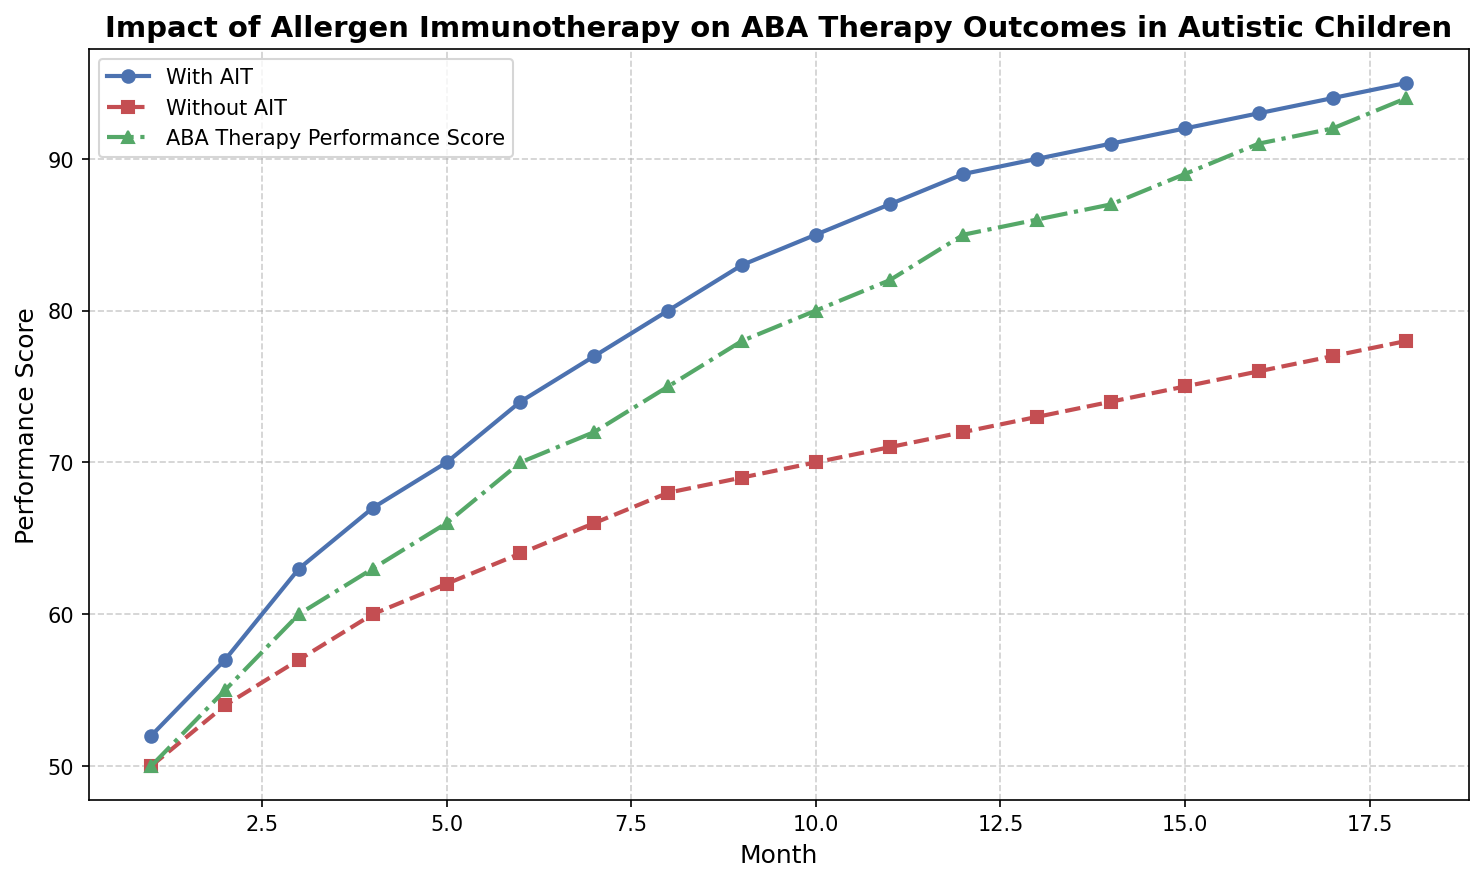What is the overall trend of the ABA Therapy Performance Score over 18 months? The ABA Therapy Performance Score shows an increasing trend over the 18 months, starting at 50 and rising to 94. This indicates an overall improvement in performance scores over time.
Answer: Increasing Comparing the 10th month scores, which group has a higher performance score, children with AIT or those without AIT? In the 10th month, children with AIT have a performance score of 85, while those without AIT have a score of 70. Therefore, children with AIT have a higher score.
Answer: Children with AIT How does the performance score for children without AIT change from the 1st month to the 18th month? The performance score for children without AIT starts at 50 in the 1st month and increases to 78 in the 18th month. The change is an increase of 28 points.
Answer: Increased by 28 points At which month do children with AIT and the general ABA Therapy Performance Score first match or exceed 85? Children with AIT first reach or exceed a score of 85 in the 10th month, while the general ABA Therapy Performance Score reaches 85 in the 12th month.
Answer: 10th month for AIT, 12th month for general What can be inferred about the effectiveness of AIT when comparing the performance scores of children with and without AIT over the entire period? By comparing the scores, it's evident that children with AIT consistently perform better than those without AIT. This suggests that AIT may have a positive impact on ABA Therapy outcomes.
Answer: AIT is likely effective What is the difference in the performance score between children with AIT and those without AIT in the 5th month? In the 5th month, the performance score for children with AIT is 70, while for those without AIT it is 62. The difference is 70 - 62 = 8.
Answer: 8 points In which month do we first observe children with AIT achieving a performance score greater than 90? Children with AIT achieve a performance score greater than 90 for the first time in the 13th month, where the score is 90.
Answer: 13th month On average, how much does the performance score of children with AIT increase per month? The performance score for children with AIT increases from 52 in the 1st month to 95 in the 18th month. The total increase is 95 - 52 = 43 points over 17 months, giving an average increase of 43/17 ≈ 2.53 per month.
Answer: Approx. 2.53 points per month Between which months is the largest single-month increase observed for children with AIT? The largest single-month increase for children with AIT appears between the 1st and 2nd months, where the score increases from 52 to 57, a difference of 5 points.
Answer: Between 1st and 2nd months 